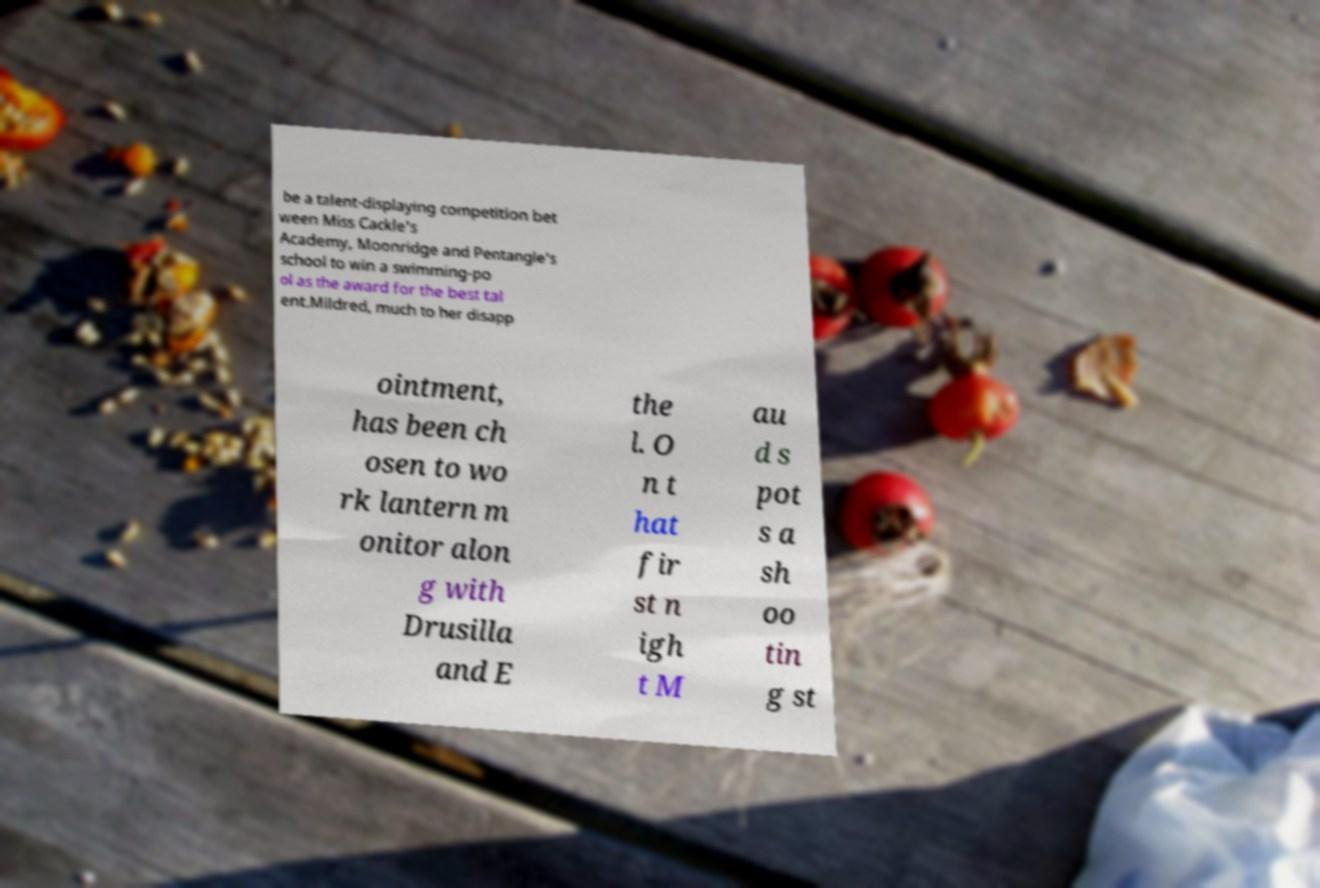Can you read and provide the text displayed in the image?This photo seems to have some interesting text. Can you extract and type it out for me? be a talent-displaying competition bet ween Miss Cackle's Academy, Moonridge and Pentangle's school to win a swimming-po ol as the award for the best tal ent.Mildred, much to her disapp ointment, has been ch osen to wo rk lantern m onitor alon g with Drusilla and E the l. O n t hat fir st n igh t M au d s pot s a sh oo tin g st 